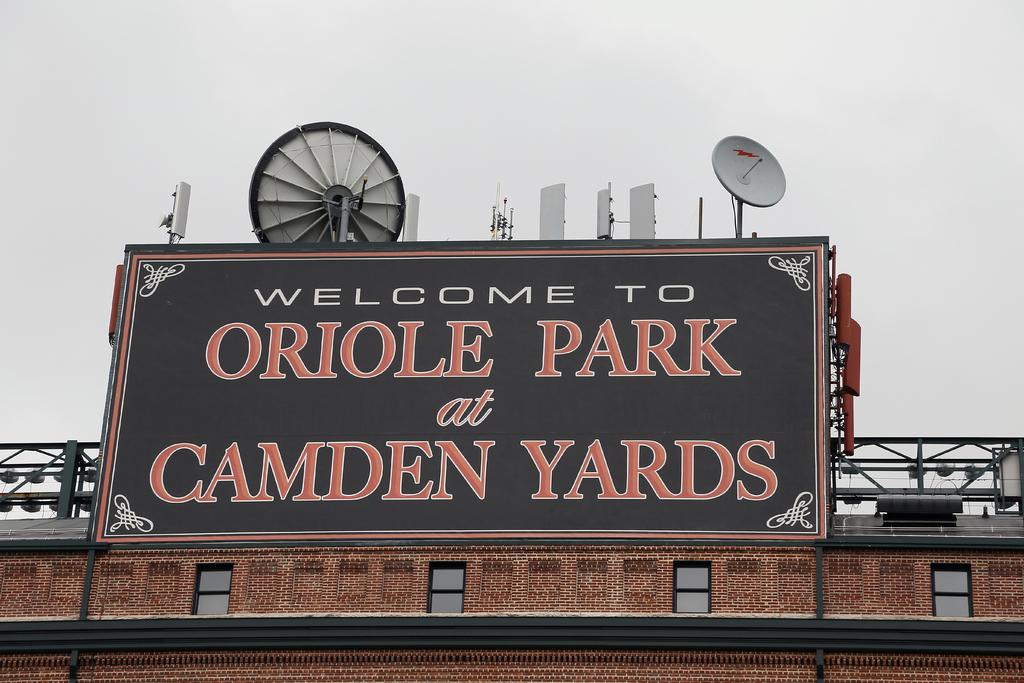What is the name of the park?
Your response must be concise. Oriole park. Is the sign welcoming you?
Ensure brevity in your answer.  Yes. 